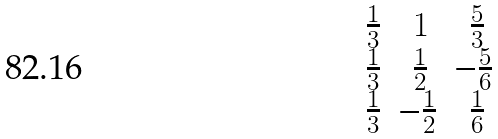<formula> <loc_0><loc_0><loc_500><loc_500>\begin{matrix} \frac { 1 } { 3 } & \, 1 & \, \frac { 5 } { 3 } \\ \frac { 1 } { 3 } & \, \frac { 1 } { 2 } & - \frac { 5 } { 6 } \\ \frac { 1 } { 3 } & - \frac { 1 } { 2 } & \, \frac { 1 } { 6 } \end{matrix}</formula> 